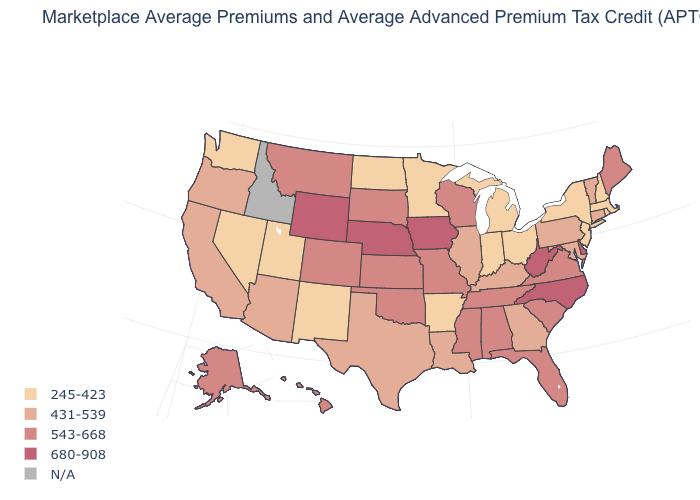How many symbols are there in the legend?
Give a very brief answer. 5. What is the value of New Hampshire?
Give a very brief answer. 245-423. Name the states that have a value in the range N/A?
Give a very brief answer. Idaho. Does the first symbol in the legend represent the smallest category?
Answer briefly. Yes. What is the value of Indiana?
Answer briefly. 245-423. Name the states that have a value in the range N/A?
Write a very short answer. Idaho. Name the states that have a value in the range 543-668?
Be succinct. Alabama, Alaska, Colorado, Florida, Hawaii, Kansas, Maine, Mississippi, Missouri, Montana, Oklahoma, South Carolina, South Dakota, Tennessee, Virginia, Wisconsin. What is the value of New Hampshire?
Concise answer only. 245-423. Among the states that border North Dakota , does South Dakota have the highest value?
Short answer required. Yes. Name the states that have a value in the range 543-668?
Keep it brief. Alabama, Alaska, Colorado, Florida, Hawaii, Kansas, Maine, Mississippi, Missouri, Montana, Oklahoma, South Carolina, South Dakota, Tennessee, Virginia, Wisconsin. Does Maine have the highest value in the Northeast?
Concise answer only. Yes. What is the value of Missouri?
Keep it brief. 543-668. Does Ohio have the lowest value in the MidWest?
Keep it brief. Yes. What is the value of Florida?
Quick response, please. 543-668. How many symbols are there in the legend?
Answer briefly. 5. 